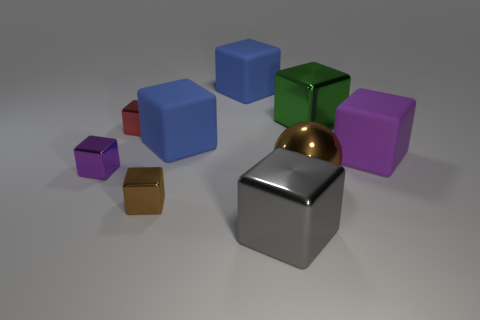Do the big shiny object behind the tiny red thing and the big brown thing in front of the small red shiny block have the same shape?
Make the answer very short. No. Is there anything else that is the same shape as the big brown thing?
Make the answer very short. No. The large matte object that is on the right side of the large brown sphere in front of the big metallic block behind the gray object is what shape?
Provide a succinct answer. Cube. There is a tiny cube that is the same color as the metallic ball; what is its material?
Your response must be concise. Metal. Does the blue thing behind the large green thing have the same material as the ball?
Make the answer very short. No. What is the shape of the purple object that is on the left side of the big sphere?
Your answer should be compact. Cube. There is a brown thing that is the same size as the green metallic thing; what is it made of?
Keep it short and to the point. Metal. What number of things are either metallic cubes that are to the right of the brown cube or large brown shiny balls that are on the right side of the tiny red shiny thing?
Make the answer very short. 3. What is the size of the purple thing that is made of the same material as the small red thing?
Offer a terse response. Small. What number of shiny things are small yellow objects or red cubes?
Provide a short and direct response. 1. 